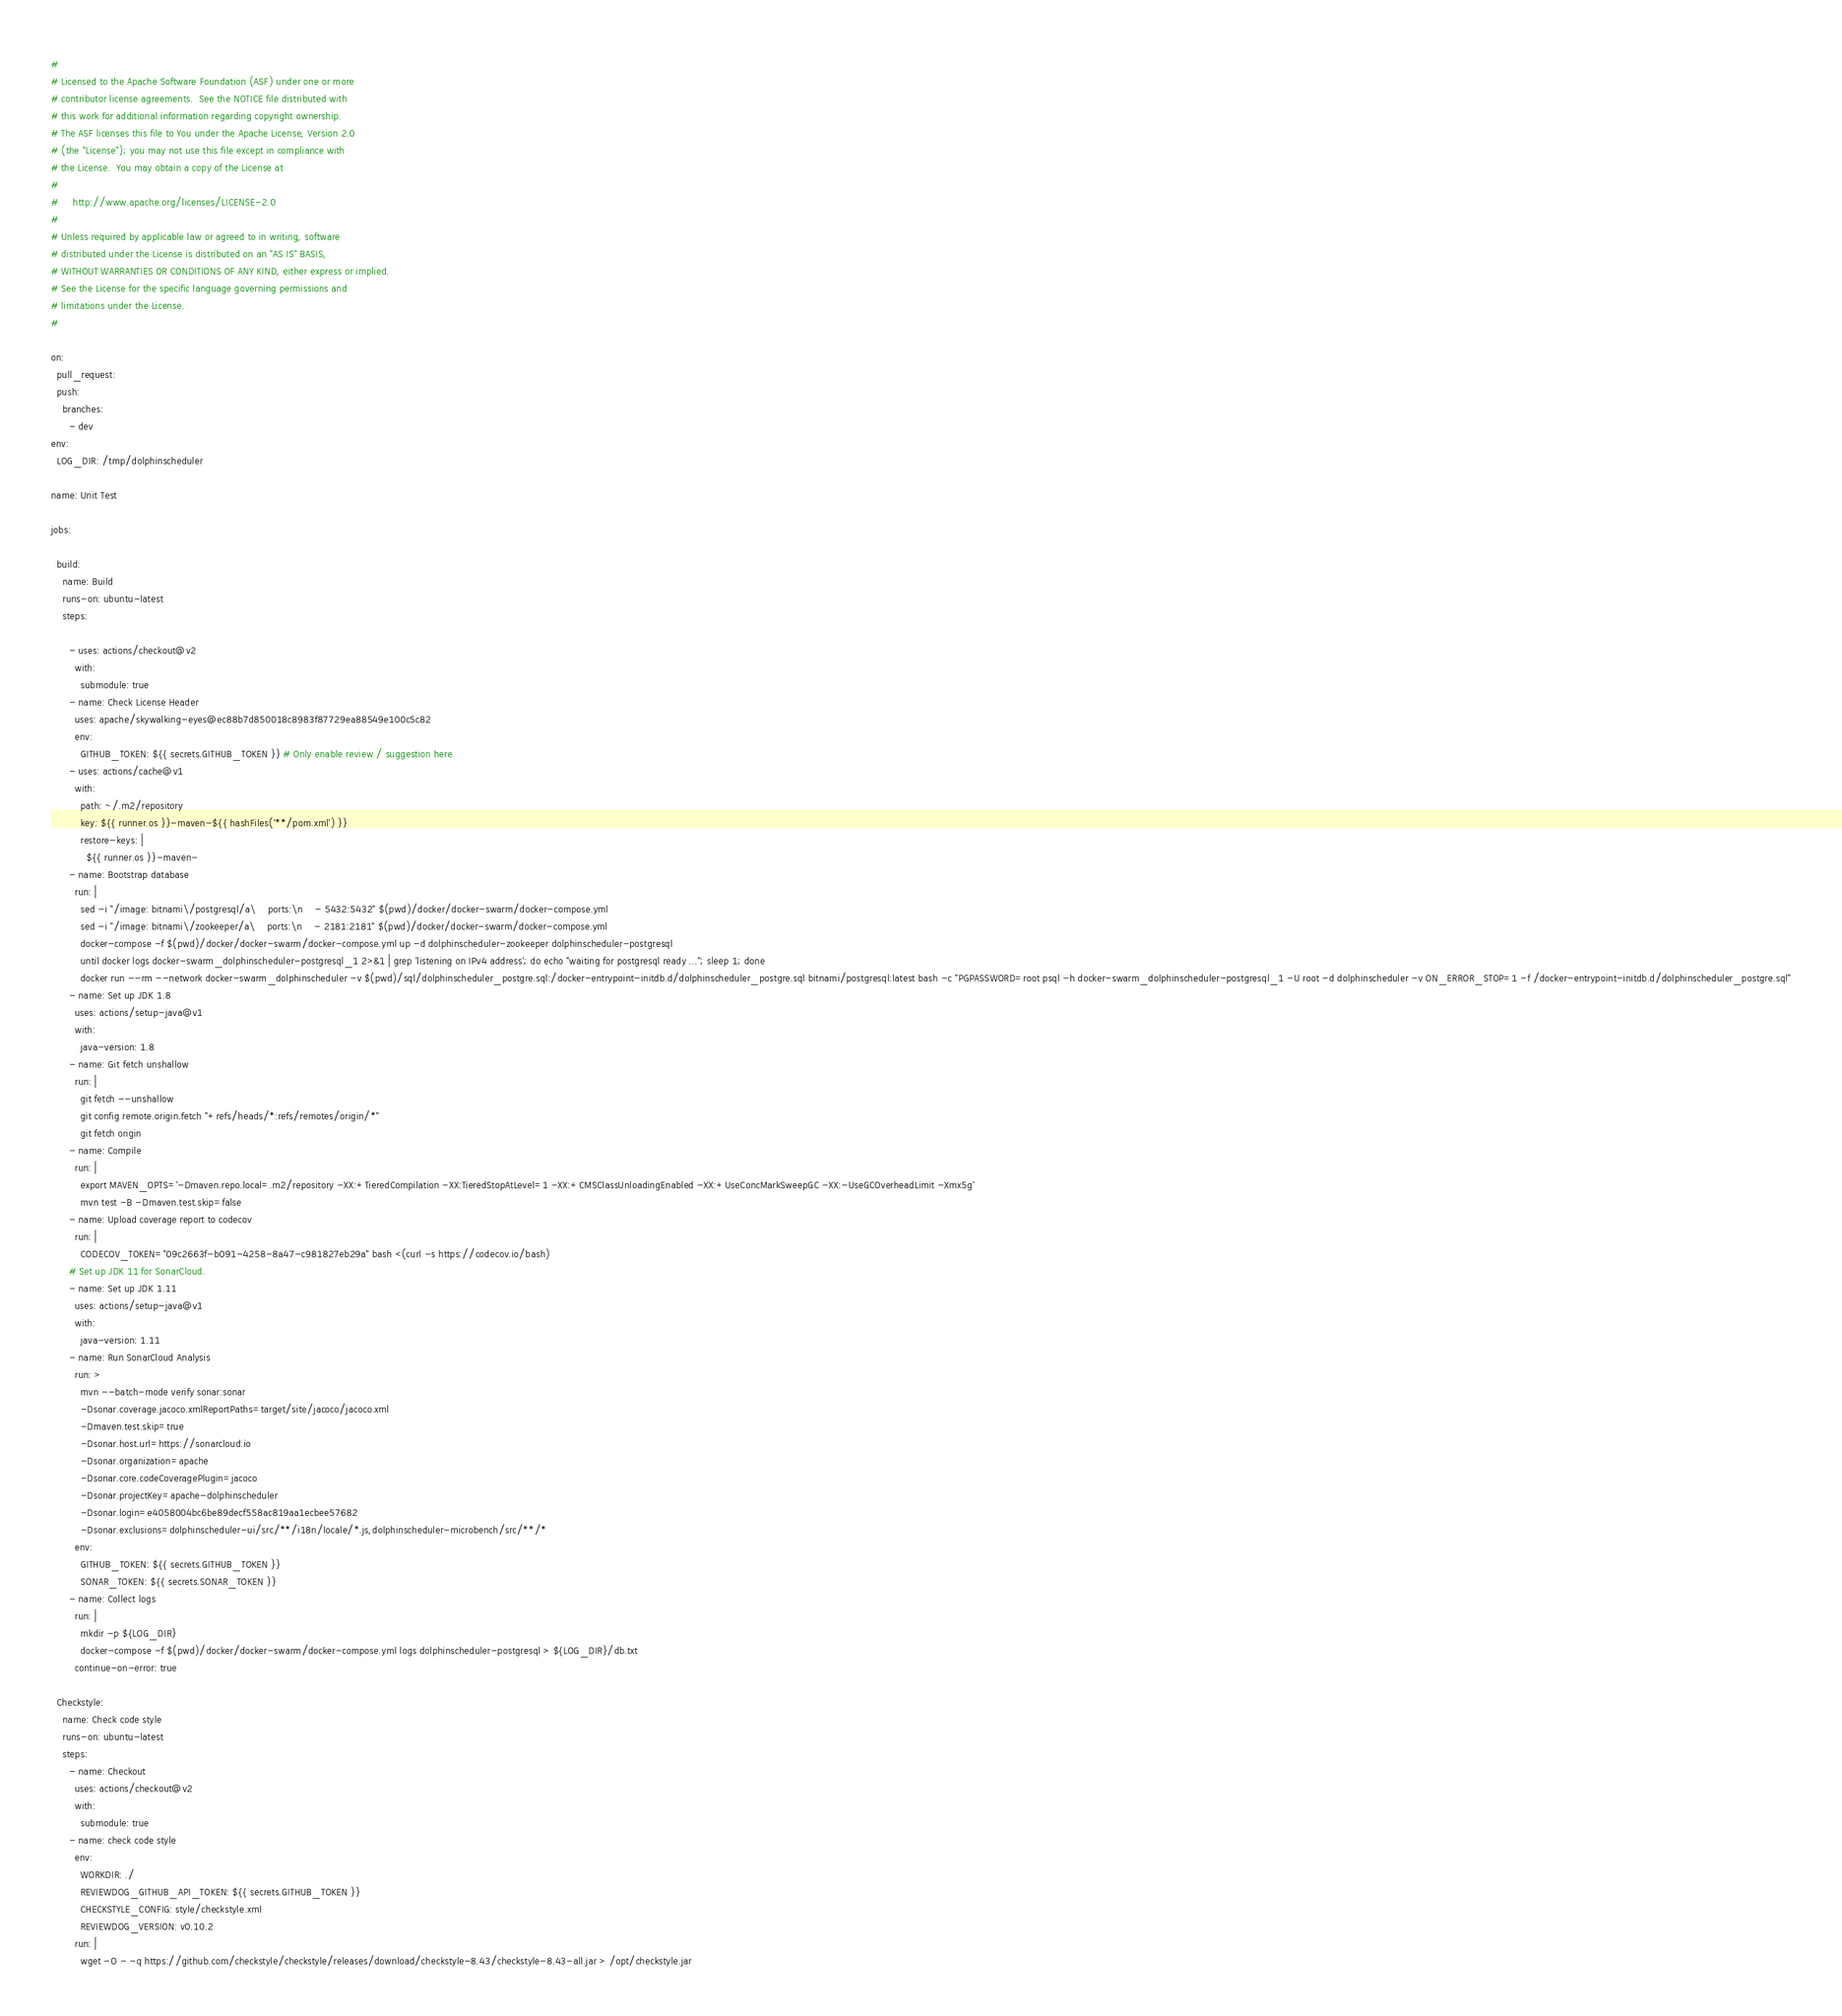<code> <loc_0><loc_0><loc_500><loc_500><_YAML_>#
# Licensed to the Apache Software Foundation (ASF) under one or more
# contributor license agreements.  See the NOTICE file distributed with
# this work for additional information regarding copyright ownership.
# The ASF licenses this file to You under the Apache License, Version 2.0
# (the "License"); you may not use this file except in compliance with
# the License.  You may obtain a copy of the License at
#
#     http://www.apache.org/licenses/LICENSE-2.0
#
# Unless required by applicable law or agreed to in writing, software
# distributed under the License is distributed on an "AS IS" BASIS,
# WITHOUT WARRANTIES OR CONDITIONS OF ANY KIND, either express or implied.
# See the License for the specific language governing permissions and
# limitations under the License.
#

on:
  pull_request:
  push:
    branches:
      - dev
env:
  LOG_DIR: /tmp/dolphinscheduler

name: Unit Test

jobs:

  build:
    name: Build
    runs-on: ubuntu-latest
    steps:

      - uses: actions/checkout@v2
        with:
          submodule: true
      - name: Check License Header
        uses: apache/skywalking-eyes@ec88b7d850018c8983f87729ea88549e100c5c82
        env:
          GITHUB_TOKEN: ${{ secrets.GITHUB_TOKEN }} # Only enable review / suggestion here
      - uses: actions/cache@v1
        with:
          path: ~/.m2/repository
          key: ${{ runner.os }}-maven-${{ hashFiles('**/pom.xml') }}
          restore-keys: |
            ${{ runner.os }}-maven-
      - name: Bootstrap database
        run: |
          sed -i "/image: bitnami\/postgresql/a\    ports:\n    - 5432:5432" $(pwd)/docker/docker-swarm/docker-compose.yml
          sed -i "/image: bitnami\/zookeeper/a\    ports:\n    - 2181:2181" $(pwd)/docker/docker-swarm/docker-compose.yml
          docker-compose -f $(pwd)/docker/docker-swarm/docker-compose.yml up -d dolphinscheduler-zookeeper dolphinscheduler-postgresql
          until docker logs docker-swarm_dolphinscheduler-postgresql_1 2>&1 | grep 'listening on IPv4 address'; do echo "waiting for postgresql ready ..."; sleep 1; done
          docker run --rm --network docker-swarm_dolphinscheduler -v $(pwd)/sql/dolphinscheduler_postgre.sql:/docker-entrypoint-initdb.d/dolphinscheduler_postgre.sql bitnami/postgresql:latest bash -c "PGPASSWORD=root psql -h docker-swarm_dolphinscheduler-postgresql_1 -U root -d dolphinscheduler -v ON_ERROR_STOP=1 -f /docker-entrypoint-initdb.d/dolphinscheduler_postgre.sql"
      - name: Set up JDK 1.8
        uses: actions/setup-java@v1
        with:
          java-version: 1.8
      - name: Git fetch unshallow
        run: |
          git fetch --unshallow
          git config remote.origin.fetch "+refs/heads/*:refs/remotes/origin/*"
          git fetch origin
      - name: Compile
        run: |
          export MAVEN_OPTS='-Dmaven.repo.local=.m2/repository -XX:+TieredCompilation -XX:TieredStopAtLevel=1 -XX:+CMSClassUnloadingEnabled -XX:+UseConcMarkSweepGC -XX:-UseGCOverheadLimit -Xmx5g'
          mvn test -B -Dmaven.test.skip=false
      - name: Upload coverage report to codecov
        run: |
          CODECOV_TOKEN="09c2663f-b091-4258-8a47-c981827eb29a" bash <(curl -s https://codecov.io/bash)
      # Set up JDK 11 for SonarCloud.
      - name: Set up JDK 1.11
        uses: actions/setup-java@v1
        with:
          java-version: 1.11
      - name: Run SonarCloud Analysis
        run: >
          mvn --batch-mode verify sonar:sonar
          -Dsonar.coverage.jacoco.xmlReportPaths=target/site/jacoco/jacoco.xml
          -Dmaven.test.skip=true
          -Dsonar.host.url=https://sonarcloud.io
          -Dsonar.organization=apache
          -Dsonar.core.codeCoveragePlugin=jacoco
          -Dsonar.projectKey=apache-dolphinscheduler
          -Dsonar.login=e4058004bc6be89decf558ac819aa1ecbee57682
          -Dsonar.exclusions=dolphinscheduler-ui/src/**/i18n/locale/*.js,dolphinscheduler-microbench/src/**/*
        env:
          GITHUB_TOKEN: ${{ secrets.GITHUB_TOKEN }}
          SONAR_TOKEN: ${{ secrets.SONAR_TOKEN }}
      - name: Collect logs
        run: |
          mkdir -p ${LOG_DIR}
          docker-compose -f $(pwd)/docker/docker-swarm/docker-compose.yml logs dolphinscheduler-postgresql > ${LOG_DIR}/db.txt
        continue-on-error: true

  Checkstyle:
    name: Check code style
    runs-on: ubuntu-latest
    steps:
      - name: Checkout
        uses: actions/checkout@v2
        with:
          submodule: true
      - name: check code style
        env:
          WORKDIR: ./
          REVIEWDOG_GITHUB_API_TOKEN: ${{ secrets.GITHUB_TOKEN }}
          CHECKSTYLE_CONFIG: style/checkstyle.xml
          REVIEWDOG_VERSION: v0.10.2
        run: |
          wget -O - -q https://github.com/checkstyle/checkstyle/releases/download/checkstyle-8.43/checkstyle-8.43-all.jar > /opt/checkstyle.jar</code> 